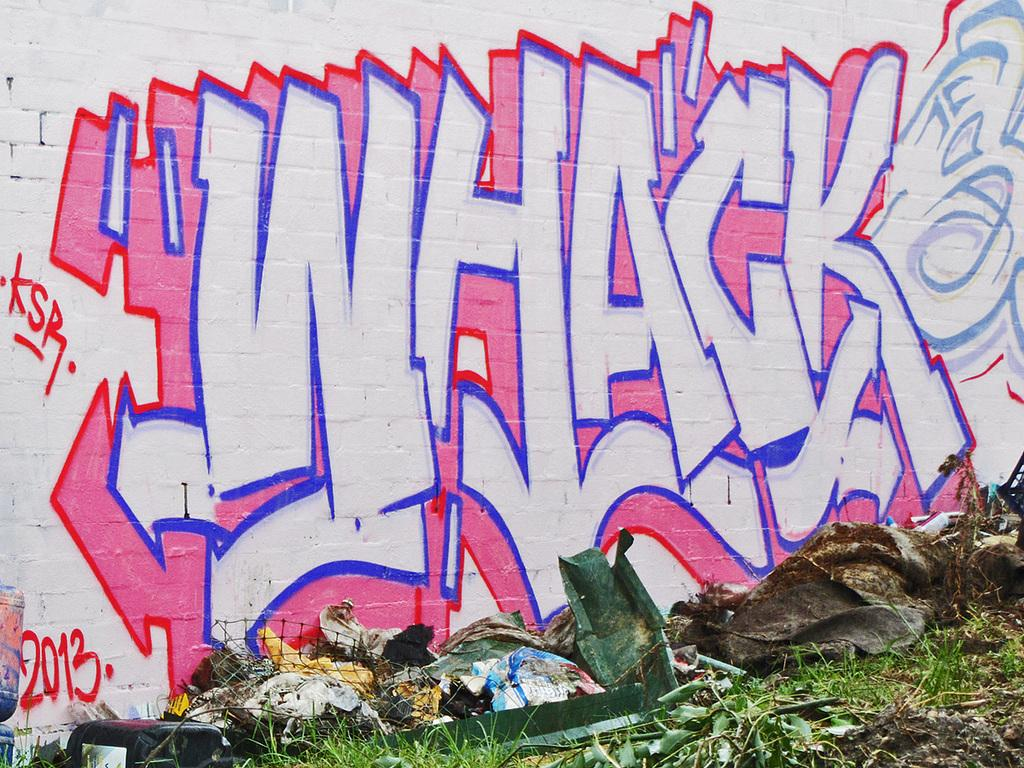What is hanging on the wall in the image? There is a painting on the wall in the image. What is located near the painting on the wall? There is a garbage with waste materials in the image. What type of natural environment can be seen in the image? Grass is visible in the image. What else can be found in the natural environment in the image? Leaves are present in the image. Where is the lamp located in the image? There is no lamp present in the image. Can you describe the bridge in the image? There is no bridge present in the image. 